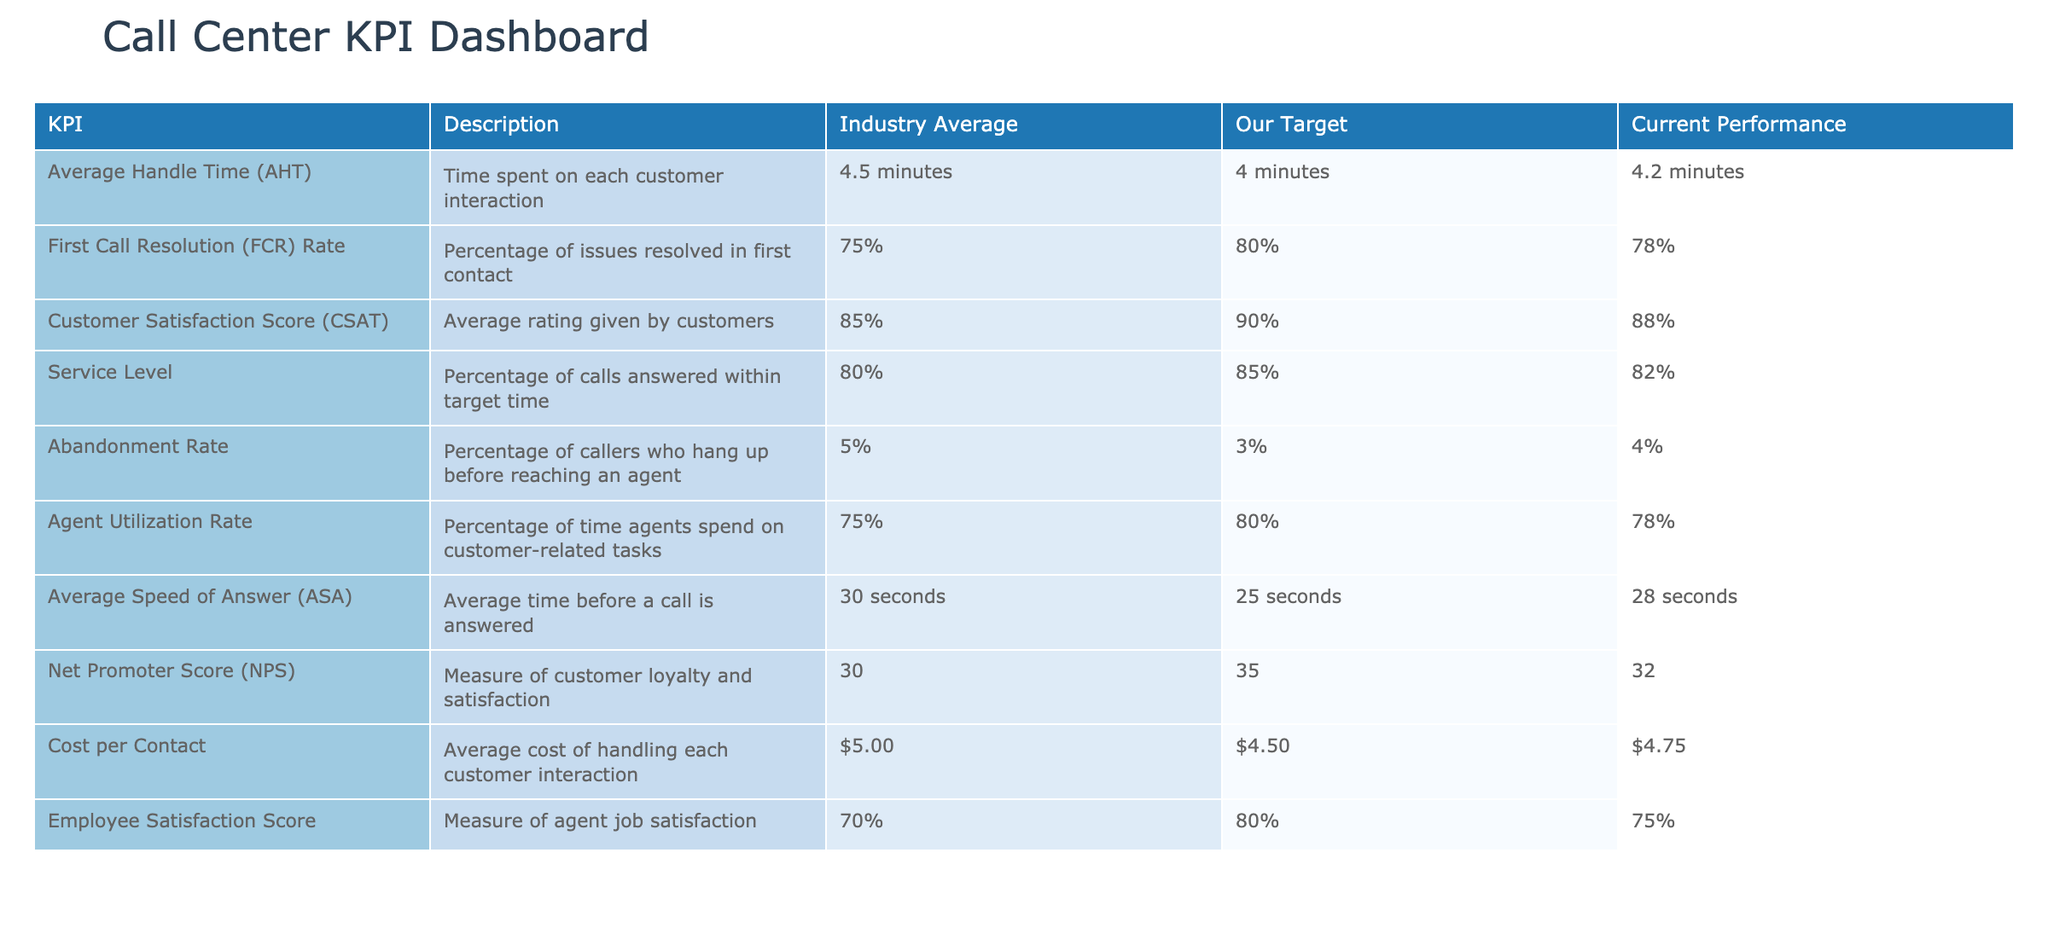What is our target for the First Call Resolution Rate? According to the table, the target for First Call Resolution Rate is 80%.
Answer: 80% What is the current performance for Average Handle Time? The table shows that our current performance for Average Handle Time is 4.2 minutes.
Answer: 4.2 minutes Is our Abandonment Rate above the industry average? The table indicates that the industry average for Abandonment Rate is 5%, and our performance is 4%. Since 4% is less than 5%, the statement is false.
Answer: No What is the difference between our target and current Customer Satisfaction Score? Our target for Customer Satisfaction Score is 90%, and the current performance is 88%. The difference is 90% - 88% = 2%.
Answer: 2% What percentage of calls were answered within the service level target? The table shows the Service Level as 82% for calls answered within the target time.
Answer: 82% Are we meeting our target for the Net Promoter Score? Our target for Net Promoter Score is 35, while the current performance is 32. Since 32 is less than 35, we are not meeting the target, making this statement false.
Answer: No What is the Average Speed of Answer, and is it below or above our target? The Average Speed of Answer is 28 seconds, which is above our target of 25 seconds. Therefore, it indicates that we are not meeting our target.
Answer: Above If we compare our Agent Utilization Rate to the Industry Average, is it below or equal? Our Agent Utilization Rate is 78%, whereas the Industry Average is 75%. Since 78% is greater than 75%, it is above the average.
Answer: Above What is the average of our Current Performance scores for Customer Satisfaction and Employee Satisfaction? The current Customer Satisfaction Score is 88%, and the Employee Satisfaction Score is 75%. To find the average, we calculate (88% + 75%) / 2 = 81.5%.
Answer: 81.5% 